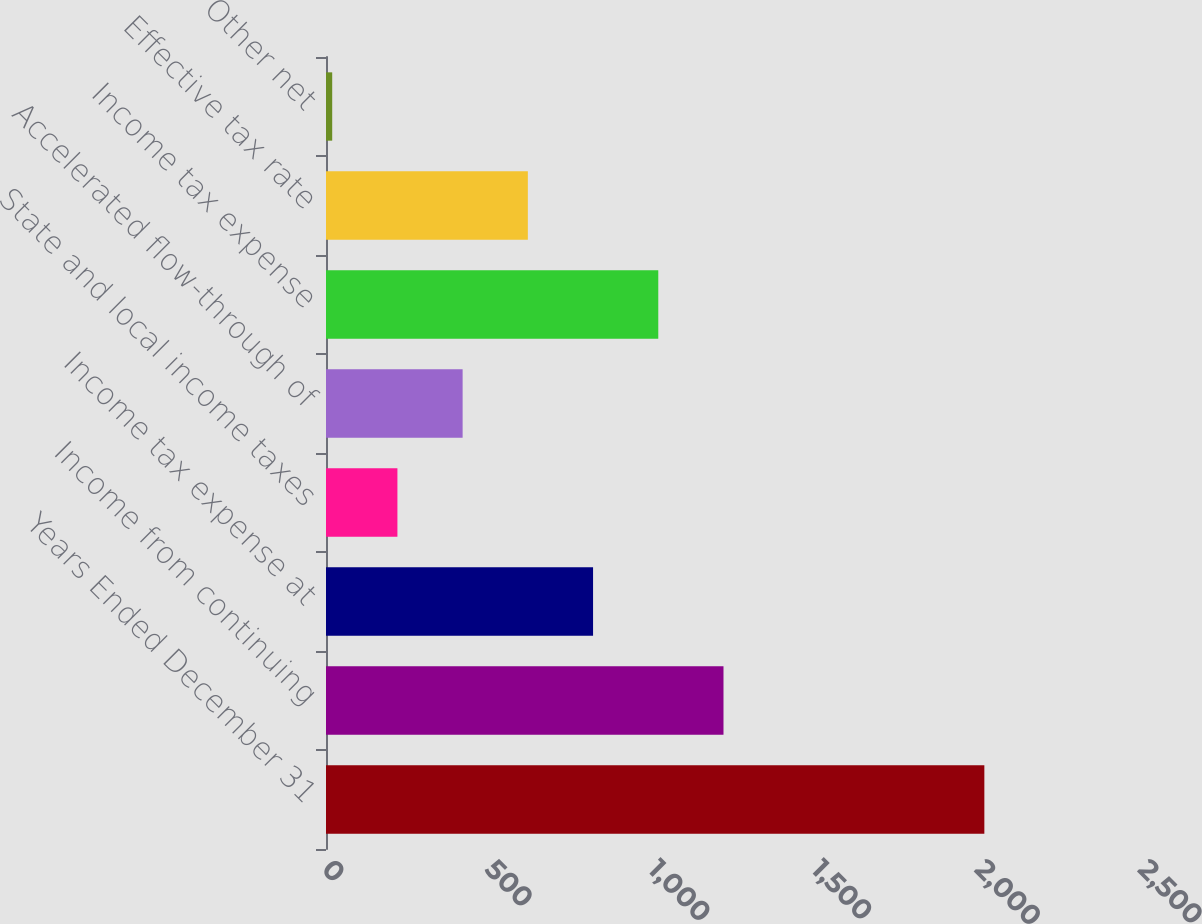Convert chart to OTSL. <chart><loc_0><loc_0><loc_500><loc_500><bar_chart><fcel>Years Ended December 31<fcel>Income from continuing<fcel>Income tax expense at<fcel>State and local income taxes<fcel>Accelerated flow-through of<fcel>Income tax expense<fcel>Effective tax rate<fcel>Other net<nl><fcel>2017<fcel>1217.8<fcel>818.2<fcel>218.8<fcel>418.6<fcel>1018<fcel>618.4<fcel>19<nl></chart> 